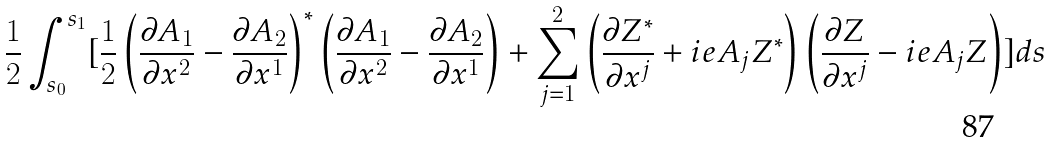Convert formula to latex. <formula><loc_0><loc_0><loc_500><loc_500>\frac { 1 } { 2 } \int _ { s _ { 0 } } ^ { s _ { 1 } } [ \frac { 1 } { 2 } \left ( \frac { \partial A _ { 1 } } { \partial x ^ { 2 } } - \frac { \partial A _ { 2 } } { \partial x ^ { 1 } } \right ) ^ { * } \left ( \frac { \partial A _ { 1 } } { \partial x ^ { 2 } } - \frac { \partial A _ { 2 } } { \partial x ^ { 1 } } \right ) + \sum _ { j = 1 } ^ { 2 } \left ( \frac { \partial Z ^ { * } } { \partial x ^ { j } } + i e A _ { j } Z ^ { * } \right ) \left ( \frac { \partial Z } { \partial x ^ { j } } - i e A _ { j } Z \right ) ] d s</formula> 